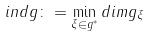<formula> <loc_0><loc_0><loc_500><loc_500>i n d g \colon = \min _ { \xi \in g ^ { * } } d i m g _ { \xi }</formula> 